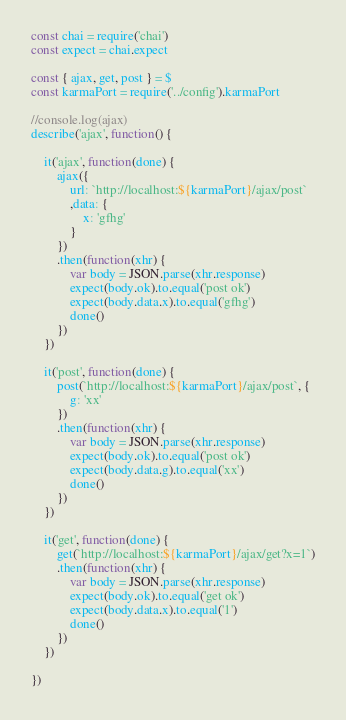<code> <loc_0><loc_0><loc_500><loc_500><_JavaScript_>
const chai = require('chai')
const expect = chai.expect

const { ajax, get, post } = $
const karmaPort = require('../config').karmaPort

//console.log(ajax)
describe('ajax', function() {

	it('ajax', function(done) {
		ajax({
			url: `http://localhost:${karmaPort}/ajax/post`
			,data: {
				x: 'gfhg'
			}
		})
		.then(function(xhr) {
			var body = JSON.parse(xhr.response)
			expect(body.ok).to.equal('post ok')
			expect(body.data.x).to.equal('gfhg')
			done()
		})
	})

	it('post', function(done) {
		post(`http://localhost:${karmaPort}/ajax/post`, {
			g: 'xx'
		})
		.then(function(xhr) {
			var body = JSON.parse(xhr.response)
			expect(body.ok).to.equal('post ok')
			expect(body.data.g).to.equal('xx')
			done()
		})
	})

	it('get', function(done) {
		get(`http://localhost:${karmaPort}/ajax/get?x=1`)
		.then(function(xhr) {
			var body = JSON.parse(xhr.response)
			expect(body.ok).to.equal('get ok')
			expect(body.data.x).to.equal('1')
			done()
		})
	})

})</code> 